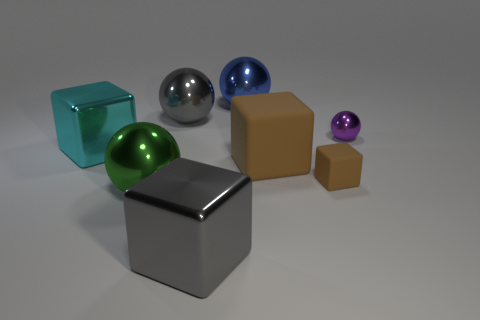There is a big brown object that is the same shape as the big cyan thing; what material is it?
Offer a terse response. Rubber. Are there any small cubes made of the same material as the gray ball?
Ensure brevity in your answer.  No. Is the color of the ball that is in front of the cyan thing the same as the small sphere?
Your answer should be very brief. No. What is the size of the gray block?
Provide a succinct answer. Large. There is a block that is in front of the brown cube that is in front of the large brown matte object; is there a cyan cube that is right of it?
Your response must be concise. No. How many large blue objects are behind the small brown matte thing?
Your response must be concise. 1. What number of big metal objects have the same color as the small shiny thing?
Provide a short and direct response. 0. How many objects are cubes that are in front of the big cyan metal object or large things that are to the left of the big blue ball?
Ensure brevity in your answer.  6. Is the number of blocks greater than the number of brown cubes?
Your answer should be compact. Yes. What color is the shiny block that is to the right of the big cyan thing?
Offer a very short reply. Gray. 